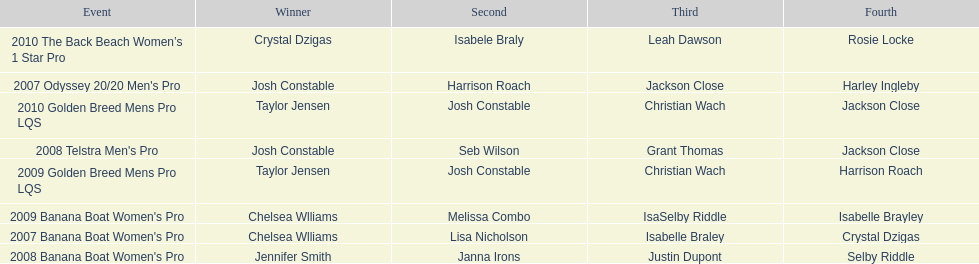Name each of the years that taylor jensen was winner. 2009, 2010. 